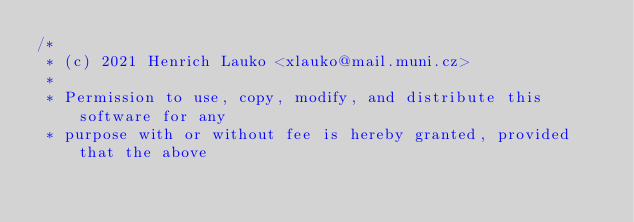<code> <loc_0><loc_0><loc_500><loc_500><_C_>/*
 * (c) 2021 Henrich Lauko <xlauko@mail.muni.cz>
 *
 * Permission to use, copy, modify, and distribute this software for any
 * purpose with or without fee is hereby granted, provided that the above</code> 